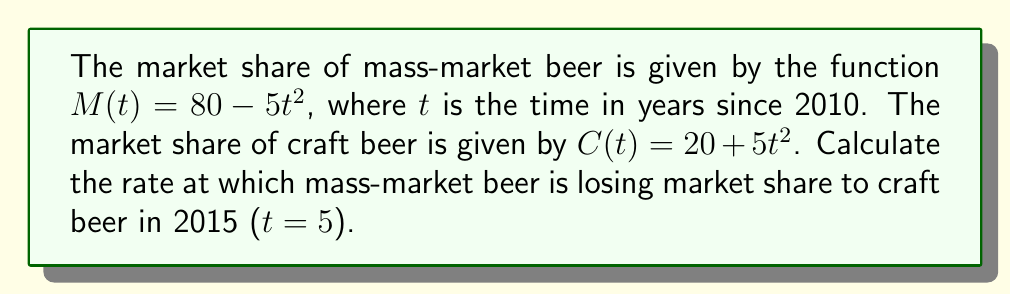Show me your answer to this math problem. 1. We need to find the rate of change of both functions at t = 5.

2. For mass-market beer:
   $M(t) = 80 - 5t^2$
   $\frac{dM}{dt} = -10t$

3. For craft beer:
   $C(t) = 20 + 5t^2$
   $\frac{dC}{dt} = 10t$

4. At t = 5:
   $\frac{dM}{dt}|_{t=5} = -10(5) = -50$
   $\frac{dC}{dt}|_{t=5} = 10(5) = 50$

5. The rate at which mass-market beer is losing market share is the negative of its derivative:
   Rate of loss = $-(-50) = 50$ percentage points per year

6. This matches the rate at which craft beer is gaining market share, confirming that the market shares are complementary.
Answer: 50 percentage points per year 